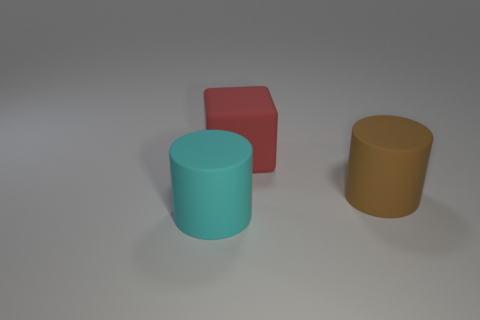Do the red matte thing and the brown matte cylinder have the same size?
Make the answer very short. Yes. What material is the brown thing that is the same shape as the large cyan rubber object?
Provide a succinct answer. Rubber. What number of red objects are rubber cubes or cylinders?
Ensure brevity in your answer.  1. There is a big cylinder on the right side of the cyan cylinder; what is its material?
Offer a very short reply. Rubber. Are there more large blocks than small yellow metallic spheres?
Provide a short and direct response. Yes. There is a thing to the left of the big red matte block; is its shape the same as the big brown object?
Your answer should be compact. Yes. What number of big matte things are both behind the brown rubber thing and in front of the large brown rubber cylinder?
Your response must be concise. 0. How many other big things are the same shape as the large brown rubber object?
Provide a short and direct response. 1. There is a rubber cylinder behind the large rubber object in front of the brown matte cylinder; what is its color?
Your response must be concise. Brown. Do the big cyan thing and the object to the right of the red block have the same shape?
Your answer should be very brief. Yes. 